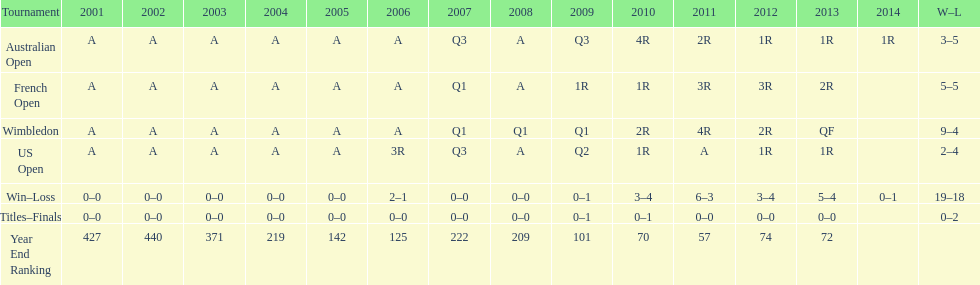I'm looking to parse the entire table for insights. Could you assist me with that? {'header': ['Tournament', '2001', '2002', '2003', '2004', '2005', '2006', '2007', '2008', '2009', '2010', '2011', '2012', '2013', '2014', 'W–L'], 'rows': [['Australian Open', 'A', 'A', 'A', 'A', 'A', 'A', 'Q3', 'A', 'Q3', '4R', '2R', '1R', '1R', '1R', '3–5'], ['French Open', 'A', 'A', 'A', 'A', 'A', 'A', 'Q1', 'A', '1R', '1R', '3R', '3R', '2R', '', '5–5'], ['Wimbledon', 'A', 'A', 'A', 'A', 'A', 'A', 'Q1', 'Q1', 'Q1', '2R', '4R', '2R', 'QF', '', '9–4'], ['US Open', 'A', 'A', 'A', 'A', 'A', '3R', 'Q3', 'A', 'Q2', '1R', 'A', '1R', '1R', '', '2–4'], ['Win–Loss', '0–0', '0–0', '0–0', '0–0', '0–0', '2–1', '0–0', '0–0', '0–1', '3–4', '6–3', '3–4', '5–4', '0–1', '19–18'], ['Titles–Finals', '0–0', '0–0', '0–0', '0–0', '0–0', '0–0', '0–0', '0–0', '0–1', '0–1', '0–0', '0–0', '0–0', '', '0–2'], ['Year End Ranking', '427', '440', '371', '219', '142', '125', '222', '209', '101', '70', '57', '74', '72', '', '']]} Comparing 2004 and 2011, which year's end ranking was superior? 2011. 